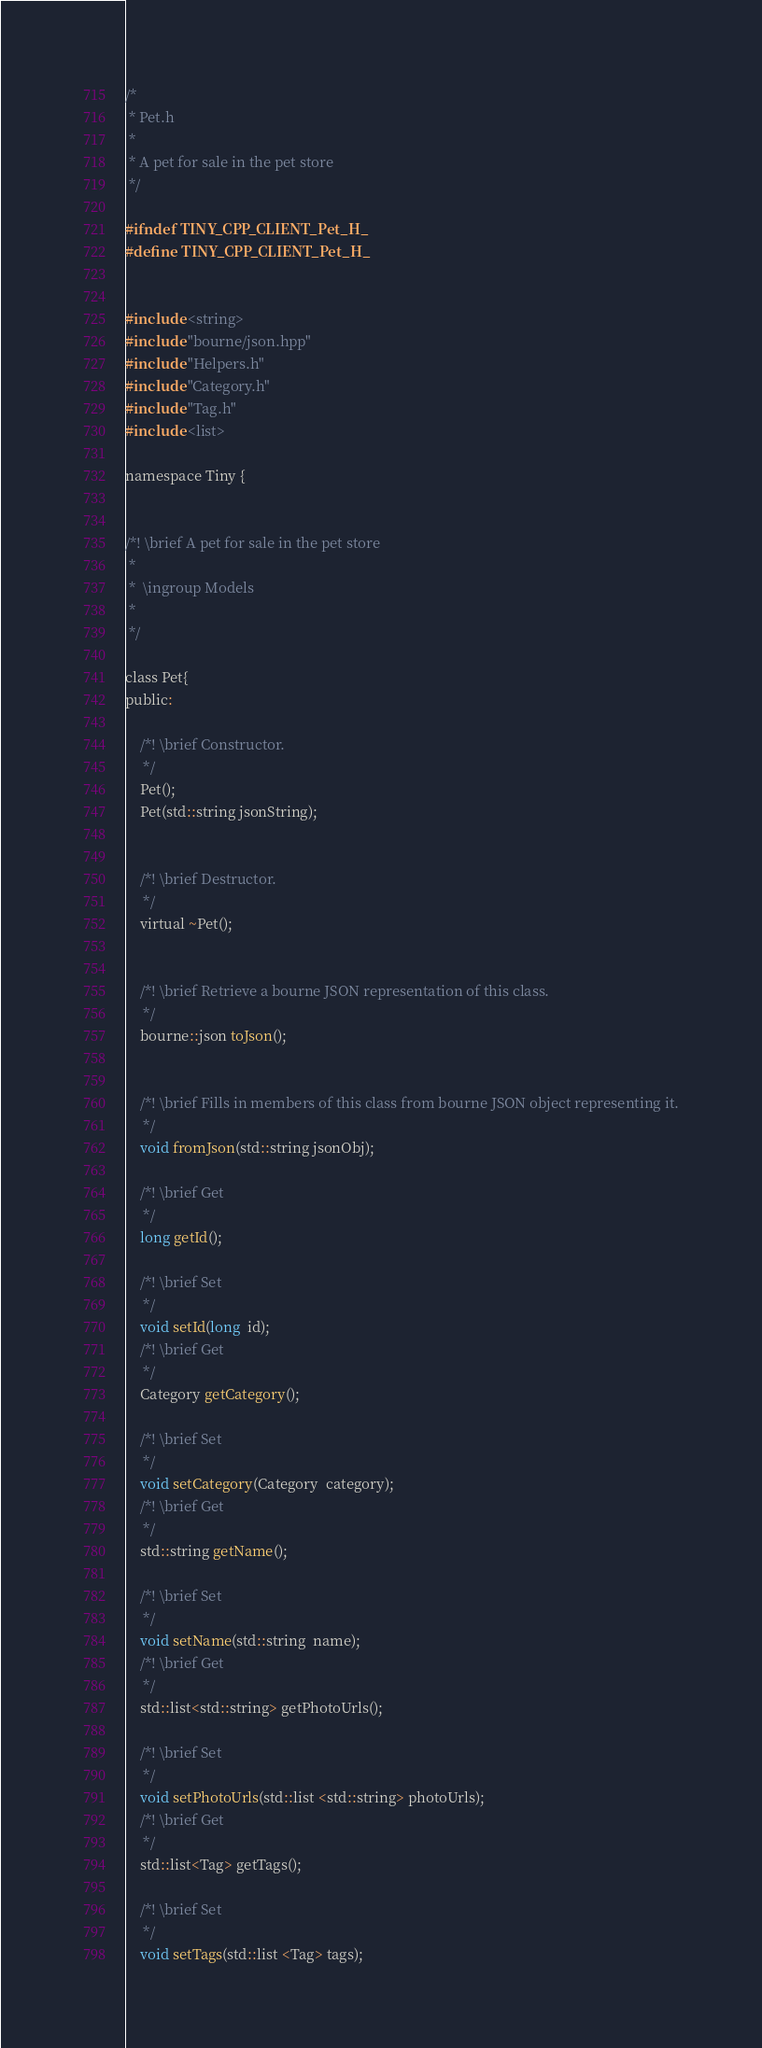Convert code to text. <code><loc_0><loc_0><loc_500><loc_500><_C_>
/*
 * Pet.h
 *
 * A pet for sale in the pet store
 */

#ifndef TINY_CPP_CLIENT_Pet_H_
#define TINY_CPP_CLIENT_Pet_H_


#include <string>
#include "bourne/json.hpp"
#include "Helpers.h"
#include "Category.h"
#include "Tag.h"
#include <list>

namespace Tiny {


/*! \brief A pet for sale in the pet store
 *
 *  \ingroup Models
 *
 */

class Pet{
public:

    /*! \brief Constructor.
	 */
    Pet();
    Pet(std::string jsonString);


    /*! \brief Destructor.
	 */
    virtual ~Pet();


    /*! \brief Retrieve a bourne JSON representation of this class.
	 */
    bourne::json toJson();


    /*! \brief Fills in members of this class from bourne JSON object representing it.
	 */
    void fromJson(std::string jsonObj);

	/*! \brief Get 
	 */
	long getId();

	/*! \brief Set 
	 */
	void setId(long  id);
	/*! \brief Get 
	 */
	Category getCategory();

	/*! \brief Set 
	 */
	void setCategory(Category  category);
	/*! \brief Get 
	 */
	std::string getName();

	/*! \brief Set 
	 */
	void setName(std::string  name);
	/*! \brief Get 
	 */
	std::list<std::string> getPhotoUrls();

	/*! \brief Set 
	 */
	void setPhotoUrls(std::list <std::string> photoUrls);
	/*! \brief Get 
	 */
	std::list<Tag> getTags();

	/*! \brief Set 
	 */
	void setTags(std::list <Tag> tags);</code> 